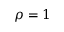<formula> <loc_0><loc_0><loc_500><loc_500>\rho = 1</formula> 